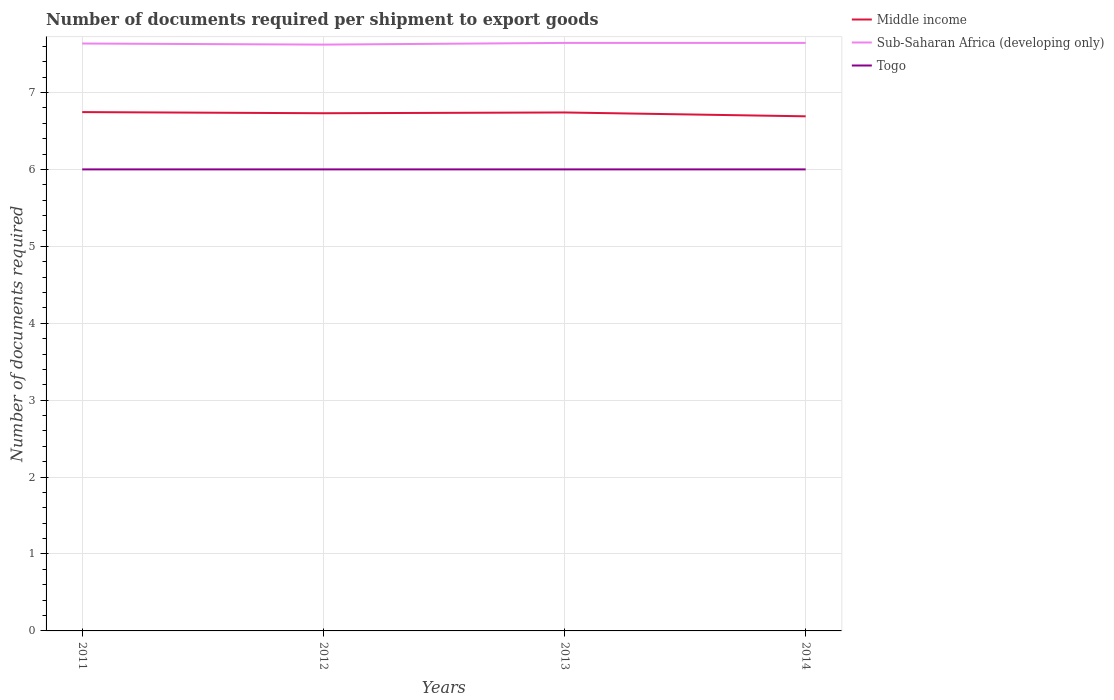How many different coloured lines are there?
Offer a very short reply. 3. Does the line corresponding to Togo intersect with the line corresponding to Sub-Saharan Africa (developing only)?
Ensure brevity in your answer.  No. Across all years, what is the maximum number of documents required per shipment to export goods in Sub-Saharan Africa (developing only)?
Provide a short and direct response. 7.62. In which year was the number of documents required per shipment to export goods in Middle income maximum?
Your answer should be very brief. 2014. What is the total number of documents required per shipment to export goods in Togo in the graph?
Give a very brief answer. 0. What is the difference between the highest and the lowest number of documents required per shipment to export goods in Togo?
Offer a terse response. 0. Is the number of documents required per shipment to export goods in Togo strictly greater than the number of documents required per shipment to export goods in Sub-Saharan Africa (developing only) over the years?
Your answer should be compact. Yes. How many lines are there?
Your answer should be compact. 3. How many years are there in the graph?
Keep it short and to the point. 4. Are the values on the major ticks of Y-axis written in scientific E-notation?
Keep it short and to the point. No. Where does the legend appear in the graph?
Your answer should be very brief. Top right. What is the title of the graph?
Provide a short and direct response. Number of documents required per shipment to export goods. What is the label or title of the X-axis?
Provide a short and direct response. Years. What is the label or title of the Y-axis?
Ensure brevity in your answer.  Number of documents required. What is the Number of documents required in Middle income in 2011?
Your response must be concise. 6.74. What is the Number of documents required of Sub-Saharan Africa (developing only) in 2011?
Ensure brevity in your answer.  7.64. What is the Number of documents required in Togo in 2011?
Provide a short and direct response. 6. What is the Number of documents required in Middle income in 2012?
Offer a terse response. 6.73. What is the Number of documents required of Sub-Saharan Africa (developing only) in 2012?
Your response must be concise. 7.62. What is the Number of documents required in Togo in 2012?
Your answer should be very brief. 6. What is the Number of documents required of Middle income in 2013?
Ensure brevity in your answer.  6.74. What is the Number of documents required in Sub-Saharan Africa (developing only) in 2013?
Keep it short and to the point. 7.64. What is the Number of documents required in Middle income in 2014?
Offer a terse response. 6.69. What is the Number of documents required of Sub-Saharan Africa (developing only) in 2014?
Offer a very short reply. 7.64. What is the Number of documents required of Togo in 2014?
Your answer should be very brief. 6. Across all years, what is the maximum Number of documents required in Middle income?
Your response must be concise. 6.74. Across all years, what is the maximum Number of documents required of Sub-Saharan Africa (developing only)?
Give a very brief answer. 7.64. Across all years, what is the minimum Number of documents required in Middle income?
Keep it short and to the point. 6.69. Across all years, what is the minimum Number of documents required of Sub-Saharan Africa (developing only)?
Ensure brevity in your answer.  7.62. Across all years, what is the minimum Number of documents required in Togo?
Provide a succinct answer. 6. What is the total Number of documents required of Middle income in the graph?
Ensure brevity in your answer.  26.9. What is the total Number of documents required in Sub-Saharan Africa (developing only) in the graph?
Your answer should be very brief. 30.55. What is the total Number of documents required of Togo in the graph?
Offer a terse response. 24. What is the difference between the Number of documents required of Middle income in 2011 and that in 2012?
Make the answer very short. 0.01. What is the difference between the Number of documents required of Sub-Saharan Africa (developing only) in 2011 and that in 2012?
Your response must be concise. 0.01. What is the difference between the Number of documents required in Togo in 2011 and that in 2012?
Provide a succinct answer. 0. What is the difference between the Number of documents required in Middle income in 2011 and that in 2013?
Provide a succinct answer. 0. What is the difference between the Number of documents required of Sub-Saharan Africa (developing only) in 2011 and that in 2013?
Ensure brevity in your answer.  -0.01. What is the difference between the Number of documents required of Middle income in 2011 and that in 2014?
Provide a short and direct response. 0.05. What is the difference between the Number of documents required in Sub-Saharan Africa (developing only) in 2011 and that in 2014?
Offer a very short reply. -0.01. What is the difference between the Number of documents required in Middle income in 2012 and that in 2013?
Make the answer very short. -0.01. What is the difference between the Number of documents required in Sub-Saharan Africa (developing only) in 2012 and that in 2013?
Your answer should be compact. -0.02. What is the difference between the Number of documents required in Sub-Saharan Africa (developing only) in 2012 and that in 2014?
Your response must be concise. -0.02. What is the difference between the Number of documents required in Togo in 2012 and that in 2014?
Keep it short and to the point. 0. What is the difference between the Number of documents required in Middle income in 2013 and that in 2014?
Make the answer very short. 0.05. What is the difference between the Number of documents required in Sub-Saharan Africa (developing only) in 2013 and that in 2014?
Keep it short and to the point. 0. What is the difference between the Number of documents required of Togo in 2013 and that in 2014?
Give a very brief answer. 0. What is the difference between the Number of documents required of Middle income in 2011 and the Number of documents required of Sub-Saharan Africa (developing only) in 2012?
Make the answer very short. -0.88. What is the difference between the Number of documents required of Middle income in 2011 and the Number of documents required of Togo in 2012?
Ensure brevity in your answer.  0.74. What is the difference between the Number of documents required of Sub-Saharan Africa (developing only) in 2011 and the Number of documents required of Togo in 2012?
Your answer should be very brief. 1.64. What is the difference between the Number of documents required in Middle income in 2011 and the Number of documents required in Sub-Saharan Africa (developing only) in 2013?
Give a very brief answer. -0.9. What is the difference between the Number of documents required in Middle income in 2011 and the Number of documents required in Togo in 2013?
Ensure brevity in your answer.  0.74. What is the difference between the Number of documents required in Sub-Saharan Africa (developing only) in 2011 and the Number of documents required in Togo in 2013?
Give a very brief answer. 1.64. What is the difference between the Number of documents required in Middle income in 2011 and the Number of documents required in Sub-Saharan Africa (developing only) in 2014?
Ensure brevity in your answer.  -0.9. What is the difference between the Number of documents required of Middle income in 2011 and the Number of documents required of Togo in 2014?
Make the answer very short. 0.74. What is the difference between the Number of documents required in Sub-Saharan Africa (developing only) in 2011 and the Number of documents required in Togo in 2014?
Keep it short and to the point. 1.64. What is the difference between the Number of documents required in Middle income in 2012 and the Number of documents required in Sub-Saharan Africa (developing only) in 2013?
Keep it short and to the point. -0.91. What is the difference between the Number of documents required in Middle income in 2012 and the Number of documents required in Togo in 2013?
Offer a very short reply. 0.73. What is the difference between the Number of documents required of Sub-Saharan Africa (developing only) in 2012 and the Number of documents required of Togo in 2013?
Make the answer very short. 1.62. What is the difference between the Number of documents required in Middle income in 2012 and the Number of documents required in Sub-Saharan Africa (developing only) in 2014?
Your answer should be compact. -0.91. What is the difference between the Number of documents required of Middle income in 2012 and the Number of documents required of Togo in 2014?
Offer a terse response. 0.73. What is the difference between the Number of documents required in Sub-Saharan Africa (developing only) in 2012 and the Number of documents required in Togo in 2014?
Give a very brief answer. 1.62. What is the difference between the Number of documents required of Middle income in 2013 and the Number of documents required of Sub-Saharan Africa (developing only) in 2014?
Ensure brevity in your answer.  -0.9. What is the difference between the Number of documents required in Middle income in 2013 and the Number of documents required in Togo in 2014?
Provide a short and direct response. 0.74. What is the difference between the Number of documents required in Sub-Saharan Africa (developing only) in 2013 and the Number of documents required in Togo in 2014?
Your answer should be compact. 1.64. What is the average Number of documents required of Middle income per year?
Provide a short and direct response. 6.73. What is the average Number of documents required in Sub-Saharan Africa (developing only) per year?
Give a very brief answer. 7.64. In the year 2011, what is the difference between the Number of documents required of Middle income and Number of documents required of Sub-Saharan Africa (developing only)?
Ensure brevity in your answer.  -0.89. In the year 2011, what is the difference between the Number of documents required of Middle income and Number of documents required of Togo?
Offer a very short reply. 0.74. In the year 2011, what is the difference between the Number of documents required of Sub-Saharan Africa (developing only) and Number of documents required of Togo?
Make the answer very short. 1.64. In the year 2012, what is the difference between the Number of documents required in Middle income and Number of documents required in Sub-Saharan Africa (developing only)?
Provide a succinct answer. -0.89. In the year 2012, what is the difference between the Number of documents required in Middle income and Number of documents required in Togo?
Your answer should be compact. 0.73. In the year 2012, what is the difference between the Number of documents required in Sub-Saharan Africa (developing only) and Number of documents required in Togo?
Your answer should be very brief. 1.62. In the year 2013, what is the difference between the Number of documents required of Middle income and Number of documents required of Sub-Saharan Africa (developing only)?
Your response must be concise. -0.9. In the year 2013, what is the difference between the Number of documents required of Middle income and Number of documents required of Togo?
Offer a terse response. 0.74. In the year 2013, what is the difference between the Number of documents required of Sub-Saharan Africa (developing only) and Number of documents required of Togo?
Make the answer very short. 1.64. In the year 2014, what is the difference between the Number of documents required of Middle income and Number of documents required of Sub-Saharan Africa (developing only)?
Ensure brevity in your answer.  -0.95. In the year 2014, what is the difference between the Number of documents required of Middle income and Number of documents required of Togo?
Provide a succinct answer. 0.69. In the year 2014, what is the difference between the Number of documents required in Sub-Saharan Africa (developing only) and Number of documents required in Togo?
Provide a succinct answer. 1.64. What is the ratio of the Number of documents required in Middle income in 2011 to that in 2013?
Give a very brief answer. 1. What is the ratio of the Number of documents required of Togo in 2011 to that in 2013?
Keep it short and to the point. 1. What is the ratio of the Number of documents required of Middle income in 2011 to that in 2014?
Keep it short and to the point. 1.01. What is the ratio of the Number of documents required in Togo in 2011 to that in 2014?
Give a very brief answer. 1. What is the ratio of the Number of documents required of Middle income in 2012 to that in 2013?
Provide a short and direct response. 1. What is the ratio of the Number of documents required of Togo in 2012 to that in 2013?
Ensure brevity in your answer.  1. What is the ratio of the Number of documents required in Middle income in 2012 to that in 2014?
Offer a very short reply. 1.01. What is the ratio of the Number of documents required in Togo in 2012 to that in 2014?
Provide a short and direct response. 1. What is the ratio of the Number of documents required in Middle income in 2013 to that in 2014?
Provide a short and direct response. 1.01. What is the ratio of the Number of documents required of Togo in 2013 to that in 2014?
Offer a terse response. 1. What is the difference between the highest and the second highest Number of documents required of Middle income?
Give a very brief answer. 0. What is the difference between the highest and the second highest Number of documents required of Sub-Saharan Africa (developing only)?
Offer a terse response. 0. What is the difference between the highest and the second highest Number of documents required of Togo?
Give a very brief answer. 0. What is the difference between the highest and the lowest Number of documents required of Middle income?
Give a very brief answer. 0.05. What is the difference between the highest and the lowest Number of documents required in Sub-Saharan Africa (developing only)?
Your answer should be very brief. 0.02. What is the difference between the highest and the lowest Number of documents required of Togo?
Provide a succinct answer. 0. 